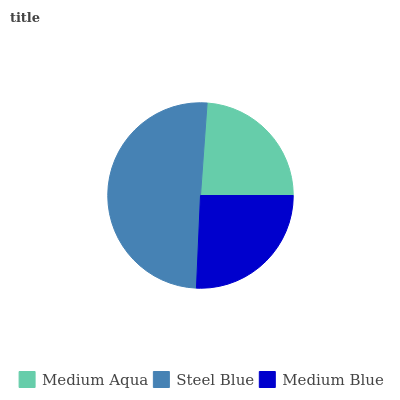Is Medium Aqua the minimum?
Answer yes or no. Yes. Is Steel Blue the maximum?
Answer yes or no. Yes. Is Medium Blue the minimum?
Answer yes or no. No. Is Medium Blue the maximum?
Answer yes or no. No. Is Steel Blue greater than Medium Blue?
Answer yes or no. Yes. Is Medium Blue less than Steel Blue?
Answer yes or no. Yes. Is Medium Blue greater than Steel Blue?
Answer yes or no. No. Is Steel Blue less than Medium Blue?
Answer yes or no. No. Is Medium Blue the high median?
Answer yes or no. Yes. Is Medium Blue the low median?
Answer yes or no. Yes. Is Steel Blue the high median?
Answer yes or no. No. Is Steel Blue the low median?
Answer yes or no. No. 